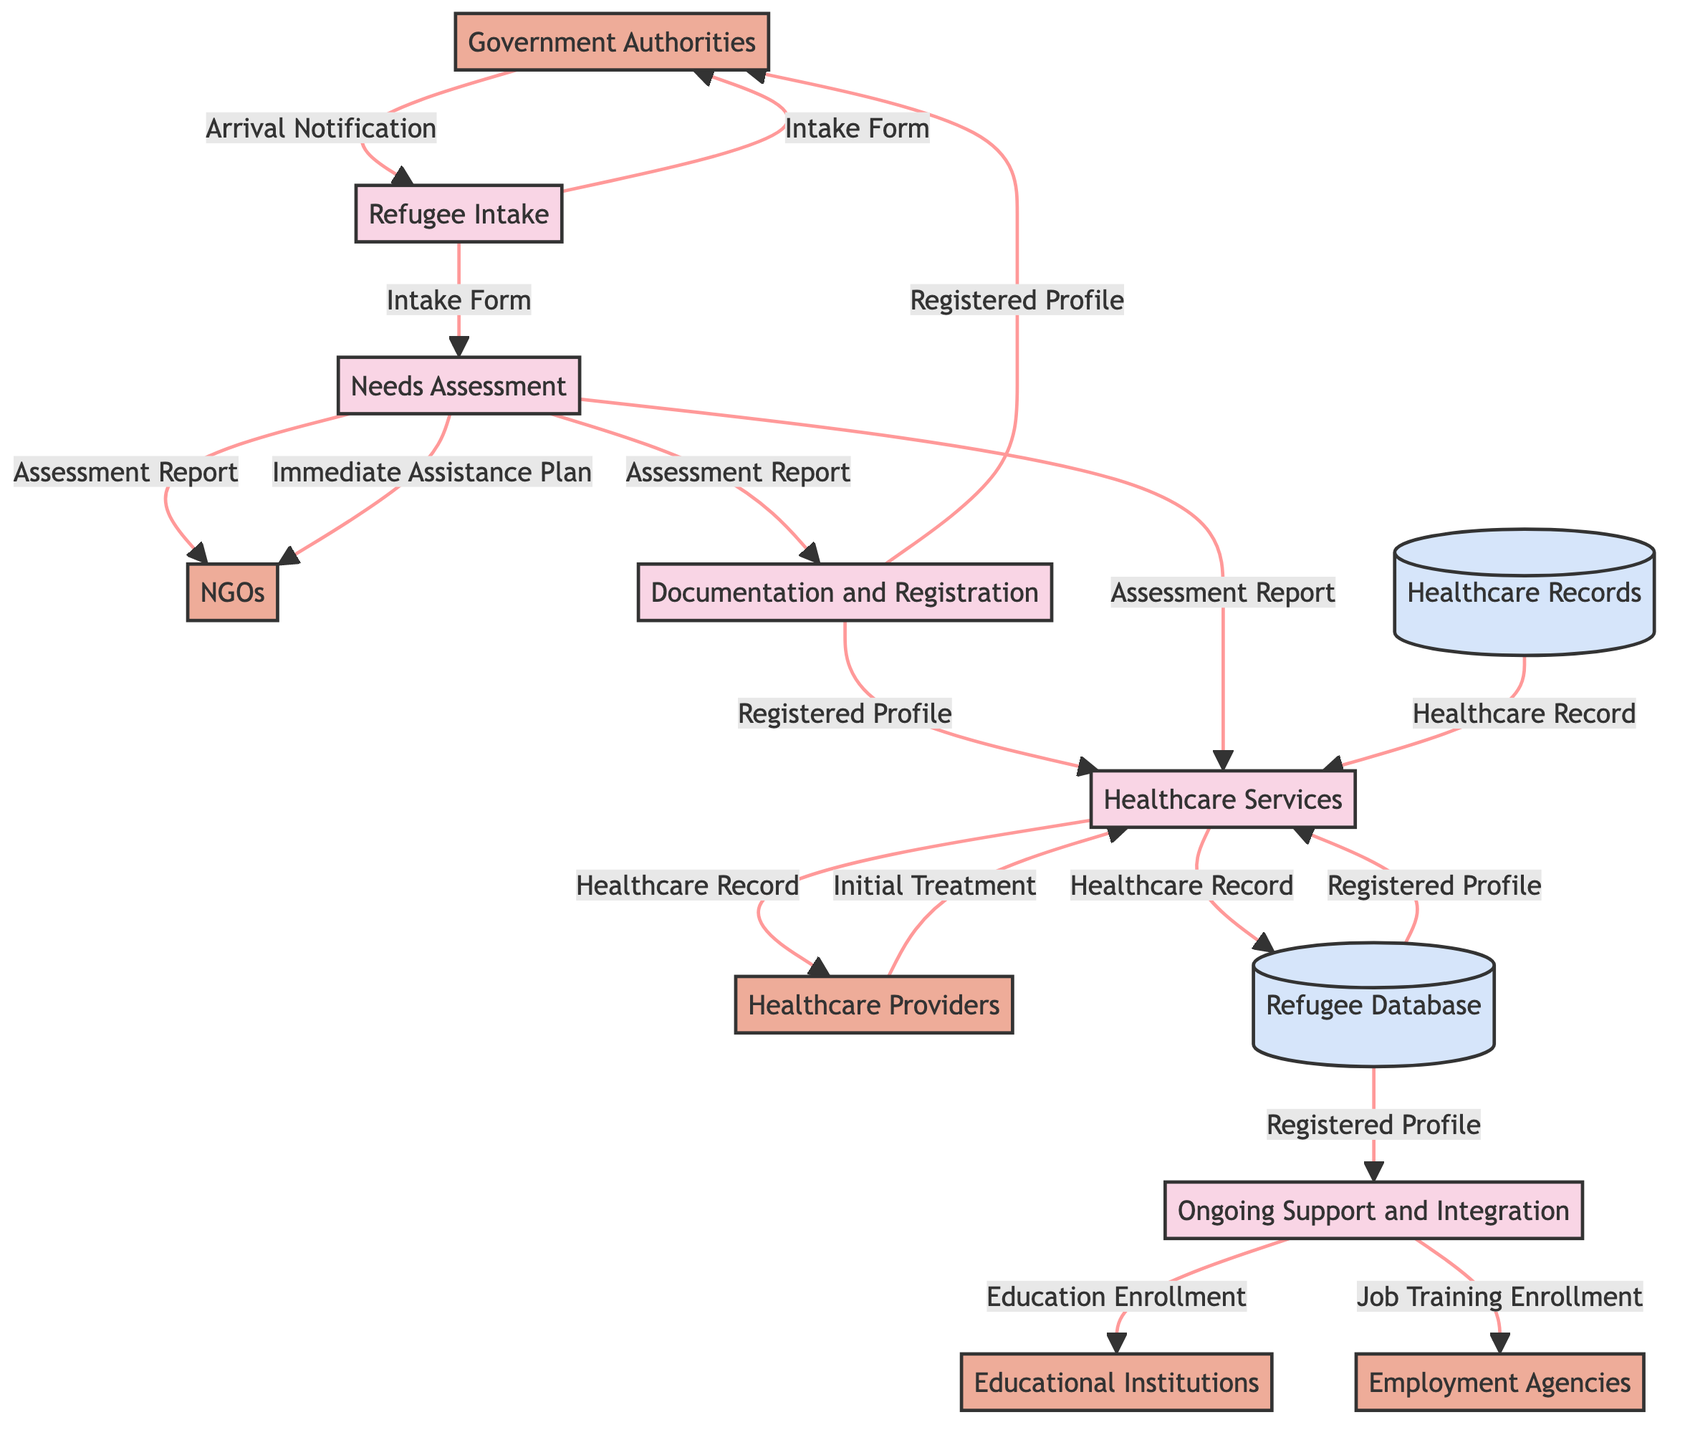What is the first process in the diagram? The first process listed in the data is "Refugee Intake," which is the starting point of the refugee support process.
Answer: Refugee Intake How many external entities are present in the diagram? There are five external entities identified in the data: Government Authorities, NGOs, Healthcare Providers, Educational Institutions, and Employment Agencies.
Answer: 5 What document flows from the Needs Assessment to the Documentation and Registration process? The data indicates that the "Assessment Report" flows from the Needs Assessment process to the Documentation and Registration process.
Answer: Assessment Report Which process outputs the "Healthcare Record"? The "Healthcare Services" process outputs the "Healthcare Record," which is also stored in the Refugee Database.
Answer: Healthcare Services What data store receives the "Healthcare Record"? The data will flow to the "Refugee Database," which is the data store that receives the "Healthcare Record" from the Healthcare Services process.
Answer: Refugee Database What is the immediate output of the "Healthcare Services" process? The immediate output of the "Healthcare Services" process is "Initial Treatment," which is a direct product of providing healthcare to refugees.
Answer: Initial Treatment How does the "Ongoing Support and Integration" process interact with Employment Agencies? The "Ongoing Support and Integration" process outputs "Job Training Enrollment" to the Employment Agencies, showing a direct relationship between providing training and facilitating employment.
Answer: Job Training Enrollment Which external entity inputs the "Registered Profile" back into the process? The "Government Authorities" input the "Registered Profile" back into the "Refugee Intake" and "Documentation and Registration" processes.
Answer: Government Authorities What is the final output from the "Needs Assessment" process? The final output from the "Needs Assessment" process includes both the "Assessment Report" and the "Immediate Assistance Plan," detailing the support provided based on assessed needs.
Answer: Assessment Report, Immediate Assistance Plan 